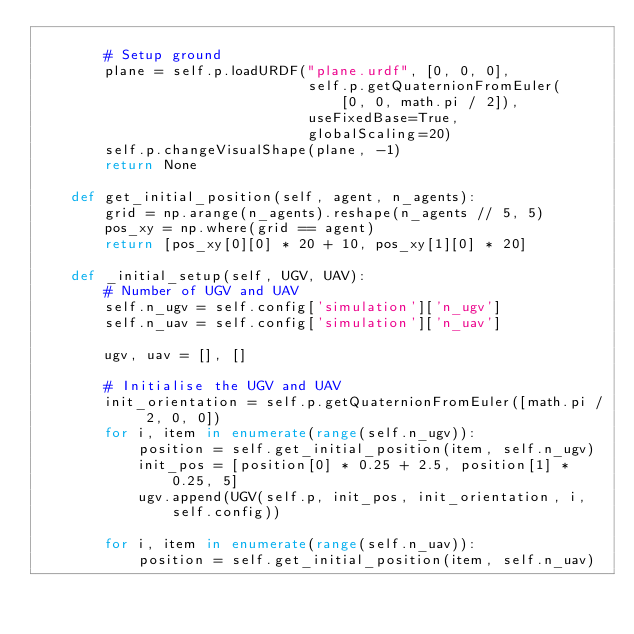Convert code to text. <code><loc_0><loc_0><loc_500><loc_500><_Python_>
        # Setup ground
        plane = self.p.loadURDF("plane.urdf", [0, 0, 0],
                                self.p.getQuaternionFromEuler(
                                    [0, 0, math.pi / 2]),
                                useFixedBase=True,
                                globalScaling=20)
        self.p.changeVisualShape(plane, -1)
        return None

    def get_initial_position(self, agent, n_agents):
        grid = np.arange(n_agents).reshape(n_agents // 5, 5)
        pos_xy = np.where(grid == agent)
        return [pos_xy[0][0] * 20 + 10, pos_xy[1][0] * 20]

    def _initial_setup(self, UGV, UAV):
        # Number of UGV and UAV
        self.n_ugv = self.config['simulation']['n_ugv']
        self.n_uav = self.config['simulation']['n_uav']

        ugv, uav = [], []

        # Initialise the UGV and UAV
        init_orientation = self.p.getQuaternionFromEuler([math.pi / 2, 0, 0])
        for i, item in enumerate(range(self.n_ugv)):
            position = self.get_initial_position(item, self.n_ugv)
            init_pos = [position[0] * 0.25 + 2.5, position[1] * 0.25, 5]
            ugv.append(UGV(self.p, init_pos, init_orientation, i, self.config))

        for i, item in enumerate(range(self.n_uav)):
            position = self.get_initial_position(item, self.n_uav)</code> 